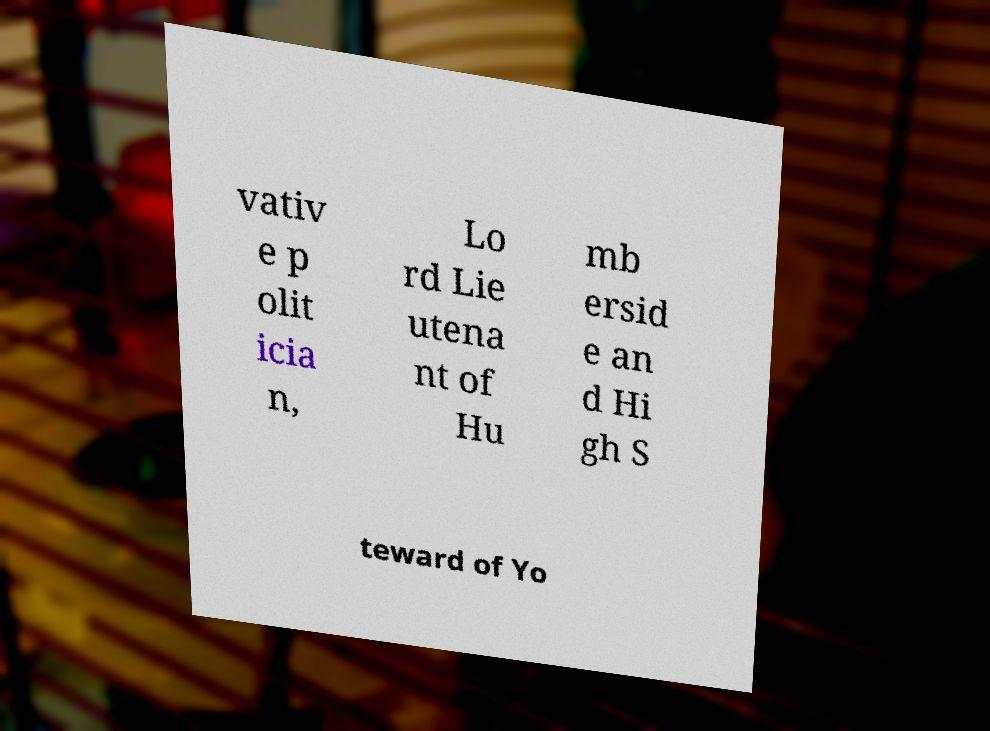Can you accurately transcribe the text from the provided image for me? vativ e p olit icia n, Lo rd Lie utena nt of Hu mb ersid e an d Hi gh S teward of Yo 